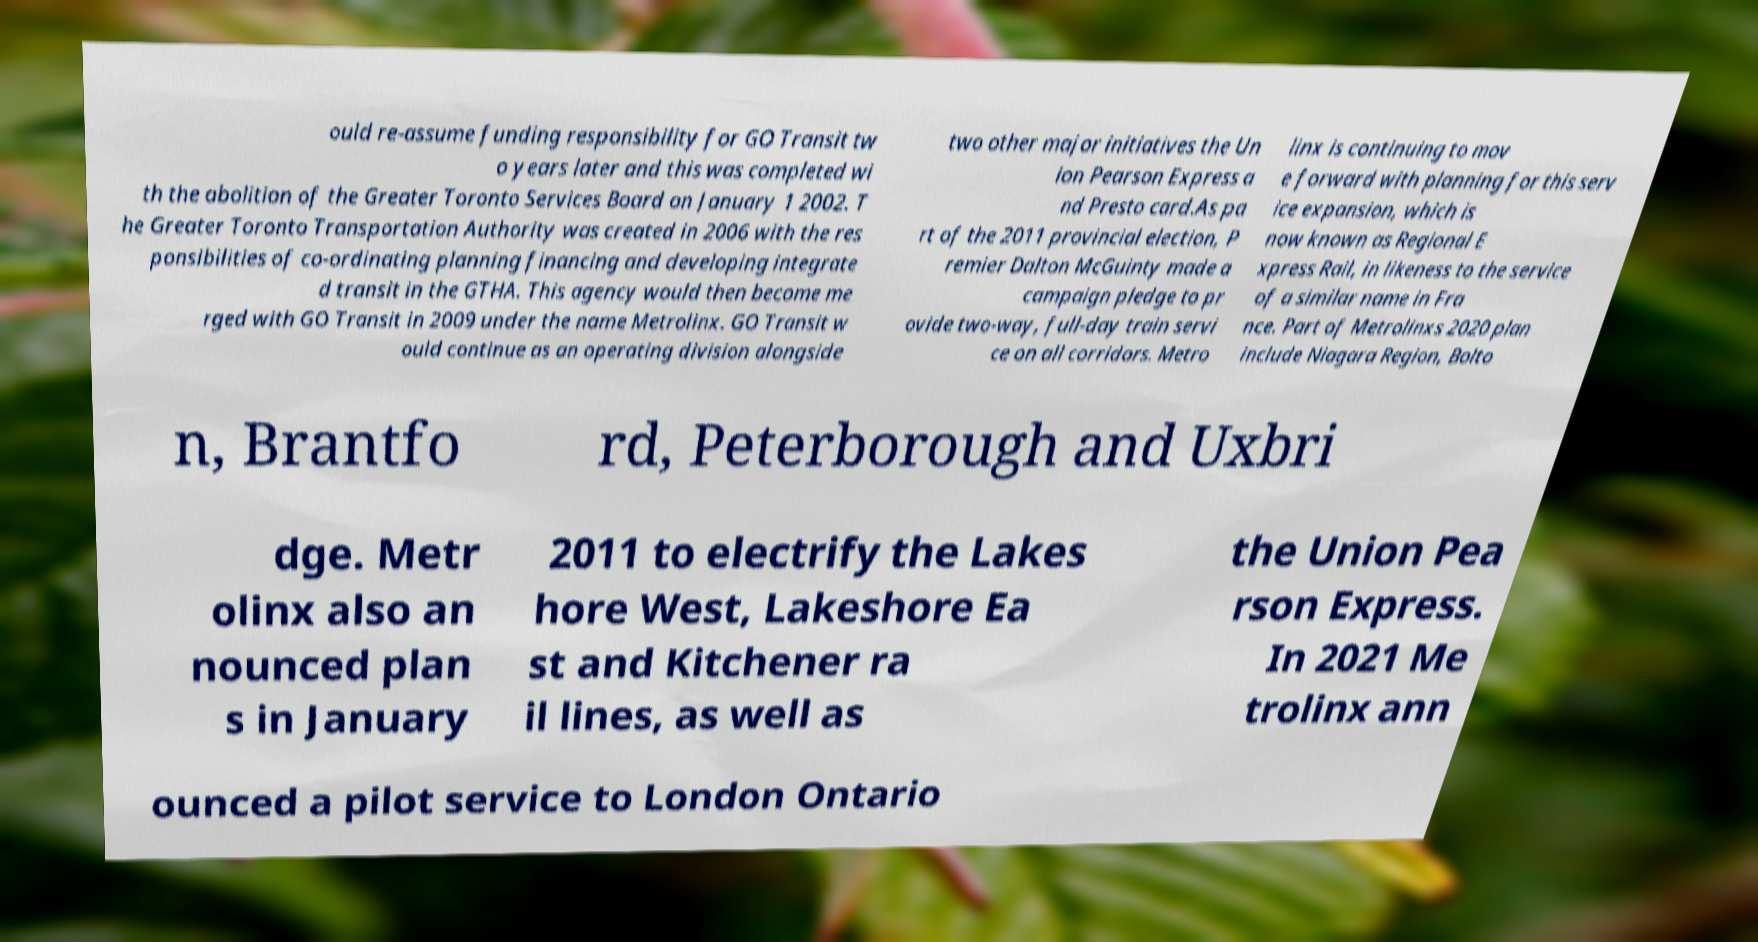There's text embedded in this image that I need extracted. Can you transcribe it verbatim? ould re-assume funding responsibility for GO Transit tw o years later and this was completed wi th the abolition of the Greater Toronto Services Board on January 1 2002. T he Greater Toronto Transportation Authority was created in 2006 with the res ponsibilities of co-ordinating planning financing and developing integrate d transit in the GTHA. This agency would then become me rged with GO Transit in 2009 under the name Metrolinx. GO Transit w ould continue as an operating division alongside two other major initiatives the Un ion Pearson Express a nd Presto card.As pa rt of the 2011 provincial election, P remier Dalton McGuinty made a campaign pledge to pr ovide two-way, full-day train servi ce on all corridors. Metro linx is continuing to mov e forward with planning for this serv ice expansion, which is now known as Regional E xpress Rail, in likeness to the service of a similar name in Fra nce. Part of Metrolinxs 2020 plan include Niagara Region, Bolto n, Brantfo rd, Peterborough and Uxbri dge. Metr olinx also an nounced plan s in January 2011 to electrify the Lakes hore West, Lakeshore Ea st and Kitchener ra il lines, as well as the Union Pea rson Express. In 2021 Me trolinx ann ounced a pilot service to London Ontario 